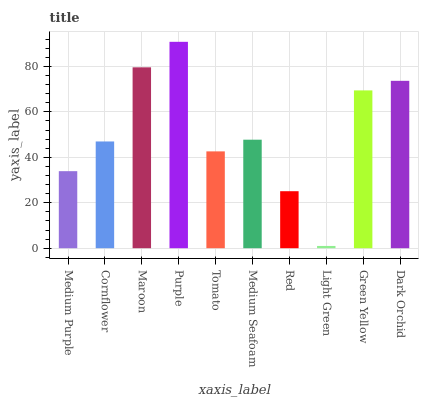Is Light Green the minimum?
Answer yes or no. Yes. Is Purple the maximum?
Answer yes or no. Yes. Is Cornflower the minimum?
Answer yes or no. No. Is Cornflower the maximum?
Answer yes or no. No. Is Cornflower greater than Medium Purple?
Answer yes or no. Yes. Is Medium Purple less than Cornflower?
Answer yes or no. Yes. Is Medium Purple greater than Cornflower?
Answer yes or no. No. Is Cornflower less than Medium Purple?
Answer yes or no. No. Is Medium Seafoam the high median?
Answer yes or no. Yes. Is Cornflower the low median?
Answer yes or no. Yes. Is Green Yellow the high median?
Answer yes or no. No. Is Purple the low median?
Answer yes or no. No. 